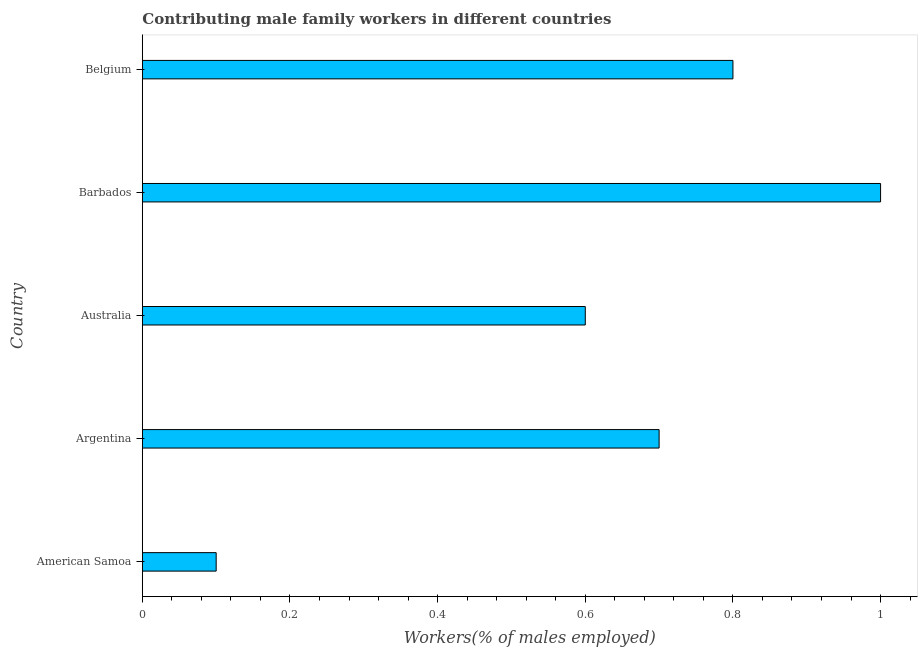What is the title of the graph?
Offer a very short reply. Contributing male family workers in different countries. What is the label or title of the X-axis?
Your answer should be very brief. Workers(% of males employed). What is the label or title of the Y-axis?
Offer a very short reply. Country. What is the contributing male family workers in Australia?
Your answer should be compact. 0.6. Across all countries, what is the minimum contributing male family workers?
Your answer should be compact. 0.1. In which country was the contributing male family workers maximum?
Offer a very short reply. Barbados. In which country was the contributing male family workers minimum?
Give a very brief answer. American Samoa. What is the sum of the contributing male family workers?
Make the answer very short. 3.2. What is the average contributing male family workers per country?
Your answer should be very brief. 0.64. What is the median contributing male family workers?
Your response must be concise. 0.7. In how many countries, is the contributing male family workers greater than 1 %?
Your answer should be very brief. 0. What is the ratio of the contributing male family workers in Australia to that in Barbados?
Offer a terse response. 0.6. Is the difference between the contributing male family workers in Australia and Barbados greater than the difference between any two countries?
Offer a very short reply. No. Is the sum of the contributing male family workers in Argentina and Belgium greater than the maximum contributing male family workers across all countries?
Ensure brevity in your answer.  Yes. What is the difference between the highest and the lowest contributing male family workers?
Your answer should be compact. 0.9. How many bars are there?
Make the answer very short. 5. Are all the bars in the graph horizontal?
Provide a succinct answer. Yes. How many countries are there in the graph?
Keep it short and to the point. 5. What is the Workers(% of males employed) of American Samoa?
Your answer should be very brief. 0.1. What is the Workers(% of males employed) of Argentina?
Your response must be concise. 0.7. What is the Workers(% of males employed) of Australia?
Offer a very short reply. 0.6. What is the Workers(% of males employed) in Barbados?
Give a very brief answer. 1. What is the Workers(% of males employed) of Belgium?
Your answer should be compact. 0.8. What is the difference between the Workers(% of males employed) in American Samoa and Australia?
Make the answer very short. -0.5. What is the difference between the Workers(% of males employed) in American Samoa and Belgium?
Offer a terse response. -0.7. What is the difference between the Workers(% of males employed) in Argentina and Belgium?
Provide a succinct answer. -0.1. What is the difference between the Workers(% of males employed) in Australia and Barbados?
Offer a terse response. -0.4. What is the difference between the Workers(% of males employed) in Australia and Belgium?
Your response must be concise. -0.2. What is the ratio of the Workers(% of males employed) in American Samoa to that in Argentina?
Provide a succinct answer. 0.14. What is the ratio of the Workers(% of males employed) in American Samoa to that in Australia?
Your answer should be compact. 0.17. What is the ratio of the Workers(% of males employed) in American Samoa to that in Belgium?
Offer a very short reply. 0.12. What is the ratio of the Workers(% of males employed) in Argentina to that in Australia?
Make the answer very short. 1.17. What is the ratio of the Workers(% of males employed) in Argentina to that in Barbados?
Your answer should be compact. 0.7. What is the ratio of the Workers(% of males employed) in Argentina to that in Belgium?
Your response must be concise. 0.88. What is the ratio of the Workers(% of males employed) in Australia to that in Barbados?
Make the answer very short. 0.6. 